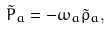<formula> <loc_0><loc_0><loc_500><loc_500>\tilde { P } _ { a } = - \omega _ { a } \tilde { \rho } _ { a } ,</formula> 